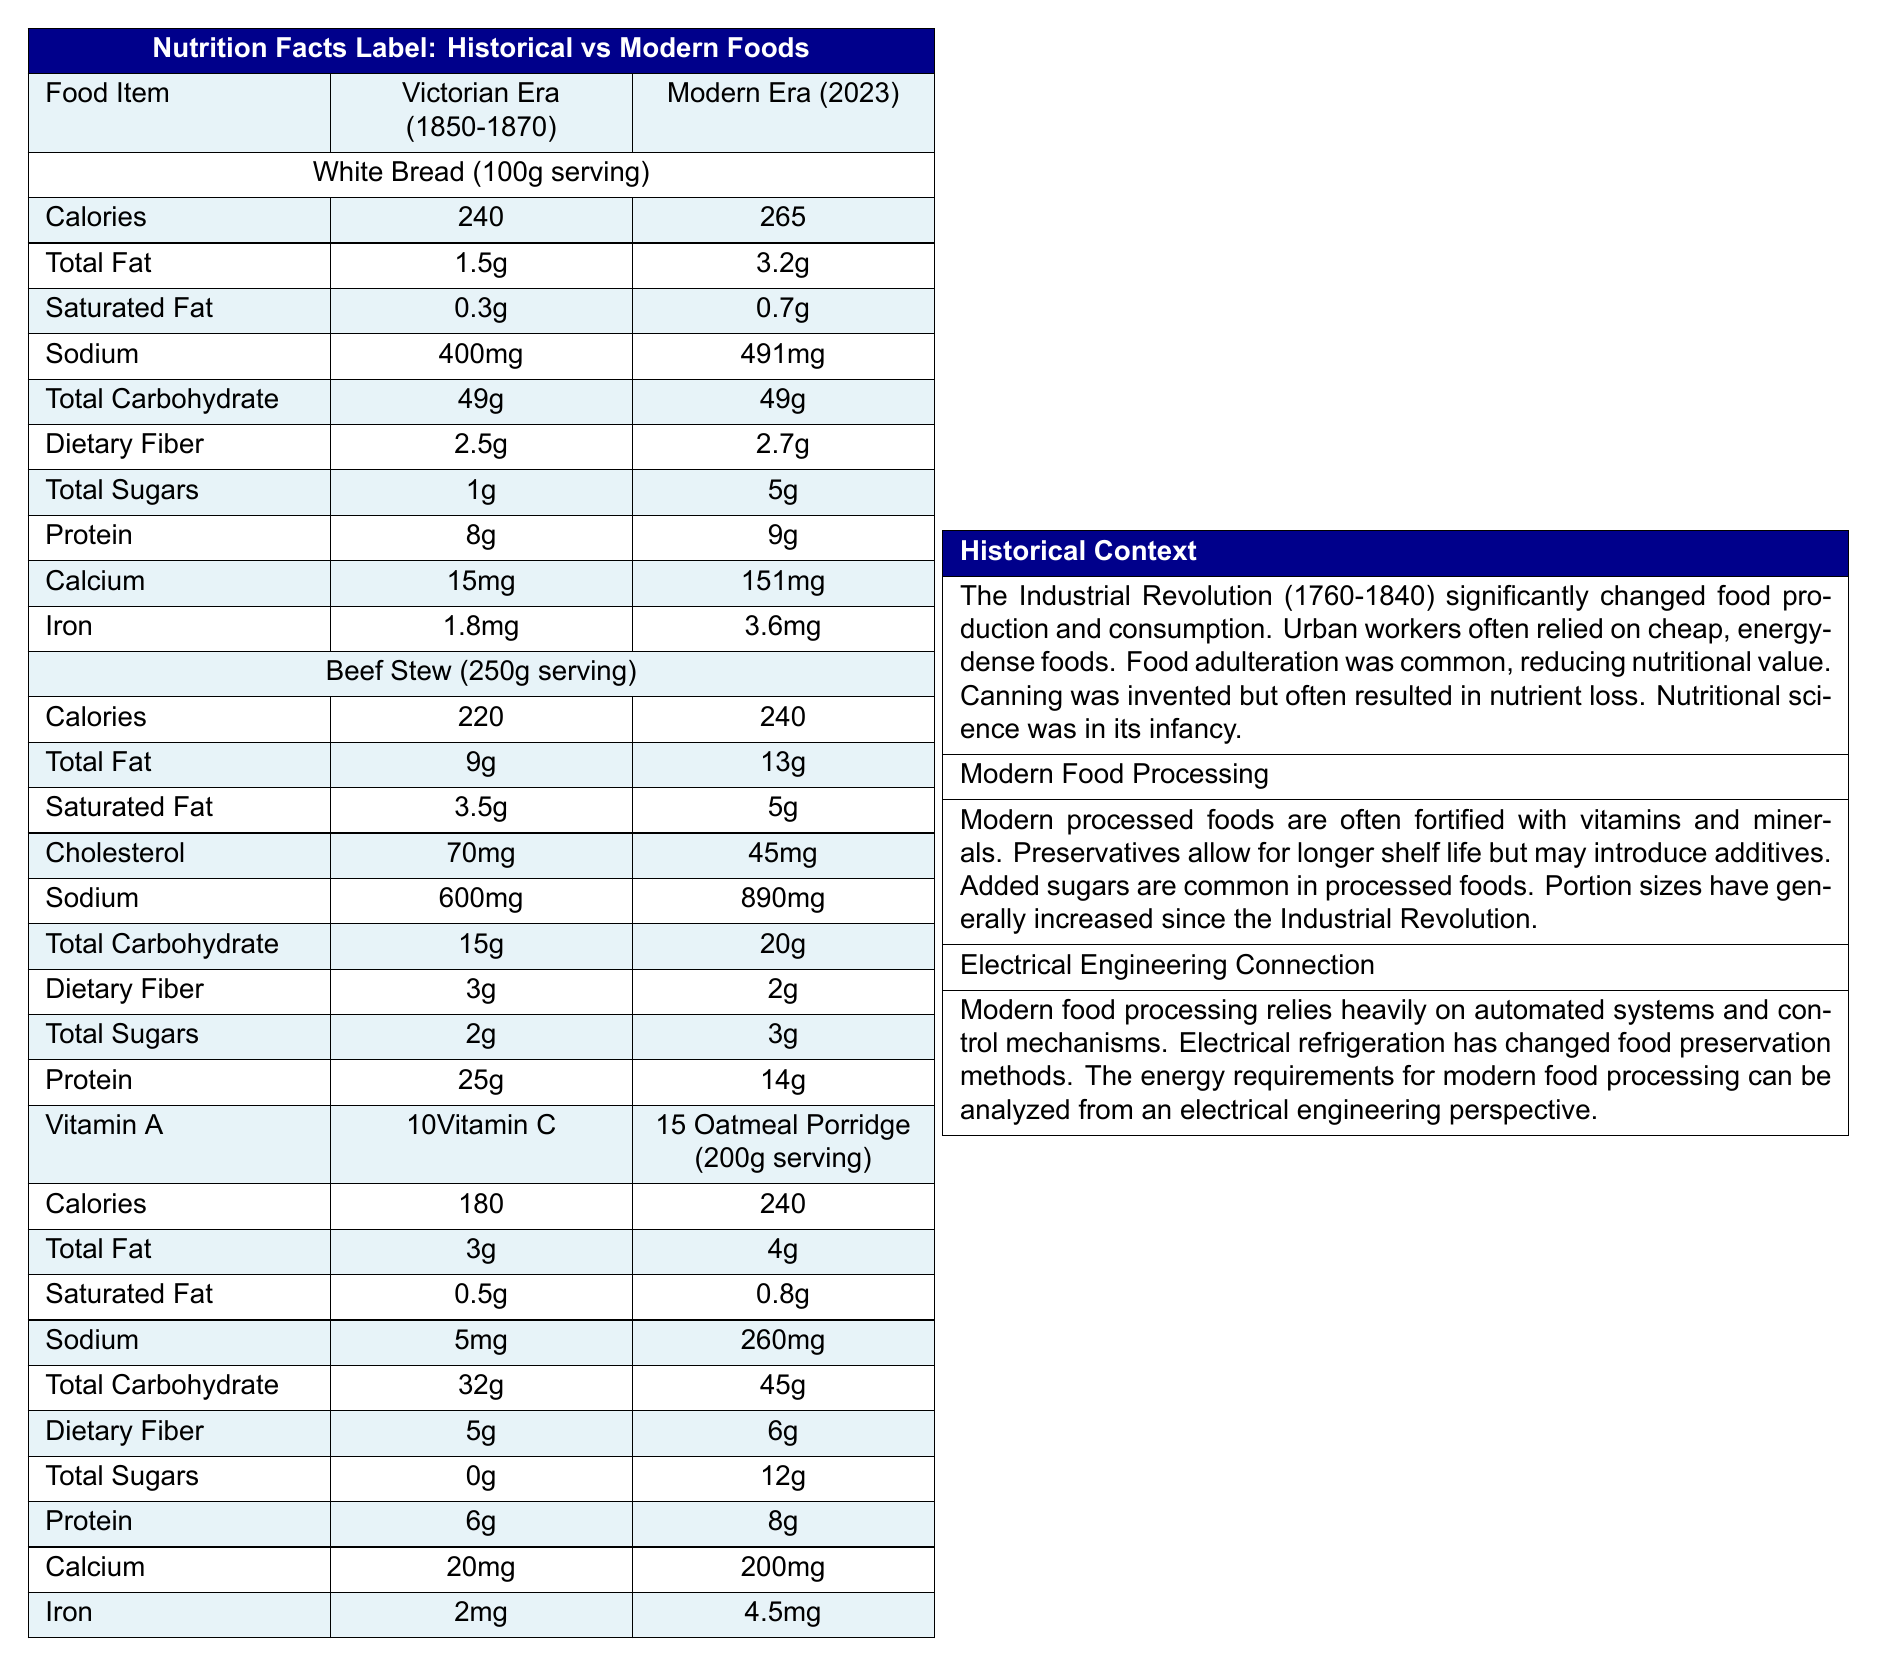what is the sodium content in modern white bread? According to the document, the sodium content in modern white bread (2023) is 491mg per 100g serving.
Answer: 491mg what are two key nutritional differences between Victorian-era and modern beef stew? Victorian-era beef stew has 9g of total fat and 600mg of sodium, while modern beef stew has 13g of total fat and 890mg of sodium.
Answer: Total fat and sodium does modern instant oatmeal contain more calories than Victorian oatmeal porridge? Modern instant oatmeal contains 240 calories per 200g serving, whereas Victorian oatmeal porridge contains 180 calories per 200g serving.
Answer: Yes how much dietary fiber is in Victorian-era white bread? The document states that Victorian-era white bread contains 2.5g of dietary fiber per 100g serving.
Answer: 2.5g which historical development significantly changed food preservation during the Industrial Revolution? The document mentions that canning was invented in the early 19th century and revolutionized food preservation.
Answer: Canning which of the following has the highest protein content per serving? A. Victorian-era White Bread B. Modern White Bread C. Victorian Oatmeal Porridge D. Modern Canned Beef Stew Modern Canned Beef Stew has the highest protein content per serving with 25g of protein in a 250g serving.
Answer: D which food item has the highest calcium content in the modern era? A. Modern White Bread B. Modern Instant Oatmeal C. Modern Canned Beef Stew Modern Instant Oatmeal contains the highest calcium content with 200mg per 200g serving.
Answer: B does modern food processing rely heavily on automated systems? The document mentions that modern food processing relies heavily on automated systems and precise control mechanisms.
Answer: Yes summarize the main idea of the document. This document presents a comparison between staple foods from the Industrial Revolution and their modern processed counterparts, focusing on nutritional differences. It provides context on historical dietary habits and food adulteration, and explains modern practices like fortification and preservation, while linking these developments to advances in electrical engineering.
Answer: The document compares the nutritional content of certain staple foods from the Industrial Revolution to modern processed versions, highlighting differences in key nutrients and discussing the impact of historical and modern food processing techniques. what were common additives used to stretch bread during the Industrial Revolution? The document only mentions additives like alum or chalk were used to stretch bread but does not provide a comprehensive list of common additives.
Answer: Not enough information 